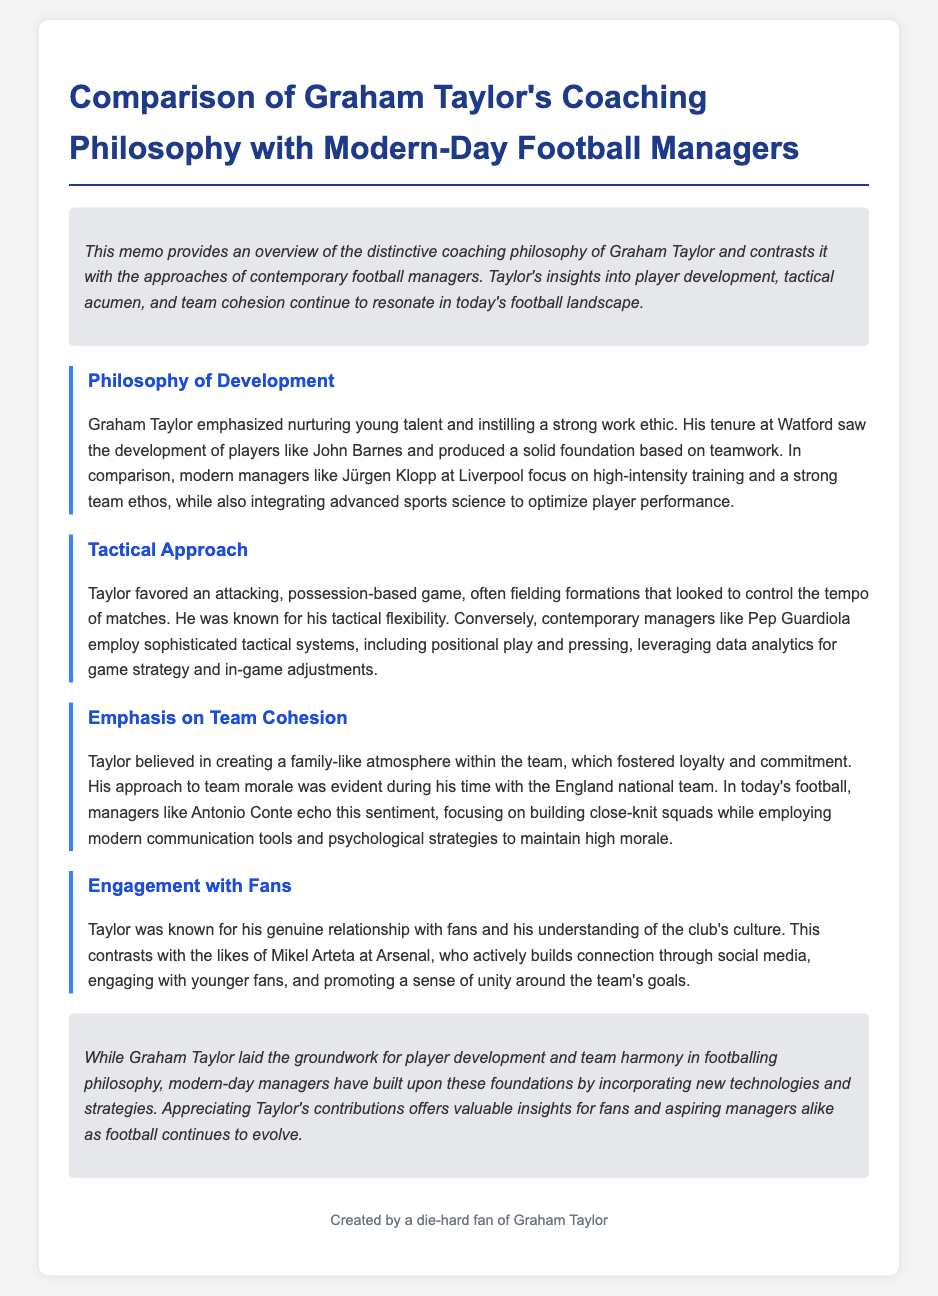What is the title of the memo? The title of the memo is explicitly stated at the beginning of the document, focusing on the comparison of coaching philosophies.
Answer: Comparison of Graham Taylor's Coaching Philosophy with Modern-Day Football Managers Who developed young players at Watford? The memo mentions Graham Taylor as the coach who emphasized nurturing young talent during his time at Watford.
Answer: Graham Taylor Which modern manager focuses on high-intensity training? The document refers to Jürgen Klopp as a contemporary manager known for his high-intensity training approach.
Answer: Jürgen Klopp What tactical philosophy did Graham Taylor prefer? The memo states that Taylor favored an attacking, possession-based game during his coaching career.
Answer: Attacking, possession-based game Which manager emphasizes team cohesion with psychological strategies? Antonio Conte is highlighted as a modern manager who focuses on team cohesion and employs psychological strategies.
Answer: Antonio Conte What is emphasized in the memo as a key component of Taylor’s approach? The memo specifically highlights team cohesion as a significant aspect of Graham Taylor’s coaching.
Answer: Team cohesion What does the document suggest about modern technologies in coaching? It indicates that modern managers build upon Taylor's foundations by integrating new technologies and strategies.
Answer: New technologies and strategies What atmosphere did Graham Taylor create within teams? The memo describes it as a family-like atmosphere, which contributed to team loyalty and commitment.
Answer: Family-like atmosphere 